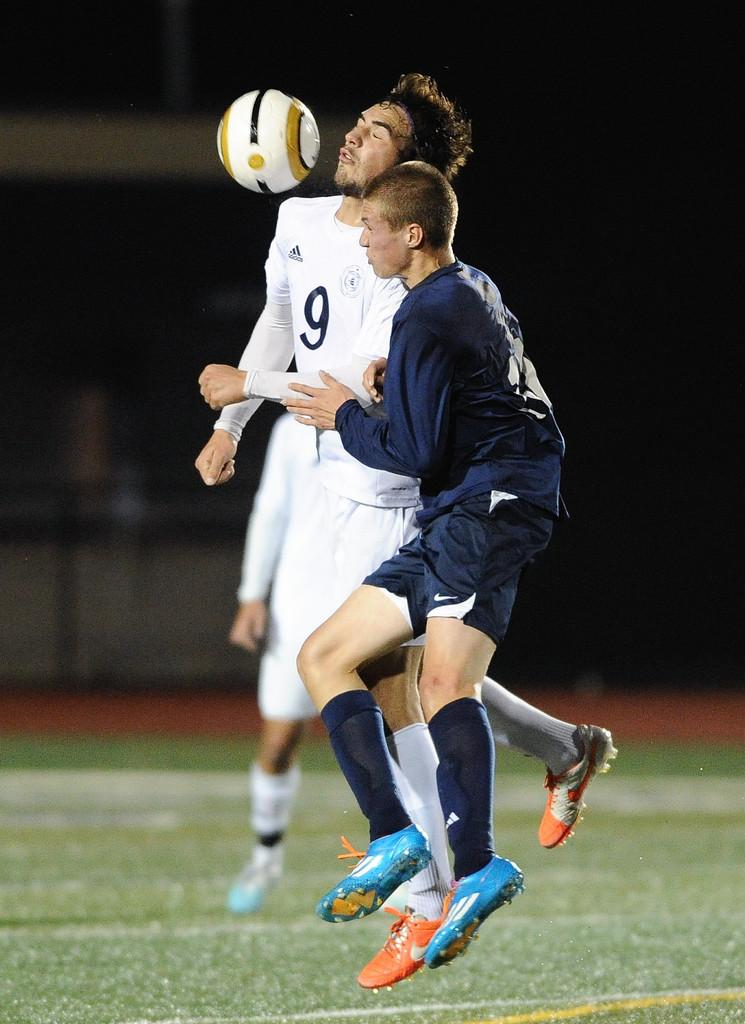<image>
Give a short and clear explanation of the subsequent image. The number 9 soccer player in a white adidas jersey is crashing into another player while heading a ball. 